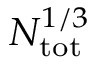<formula> <loc_0><loc_0><loc_500><loc_500>N _ { t o t } ^ { 1 / 3 }</formula> 